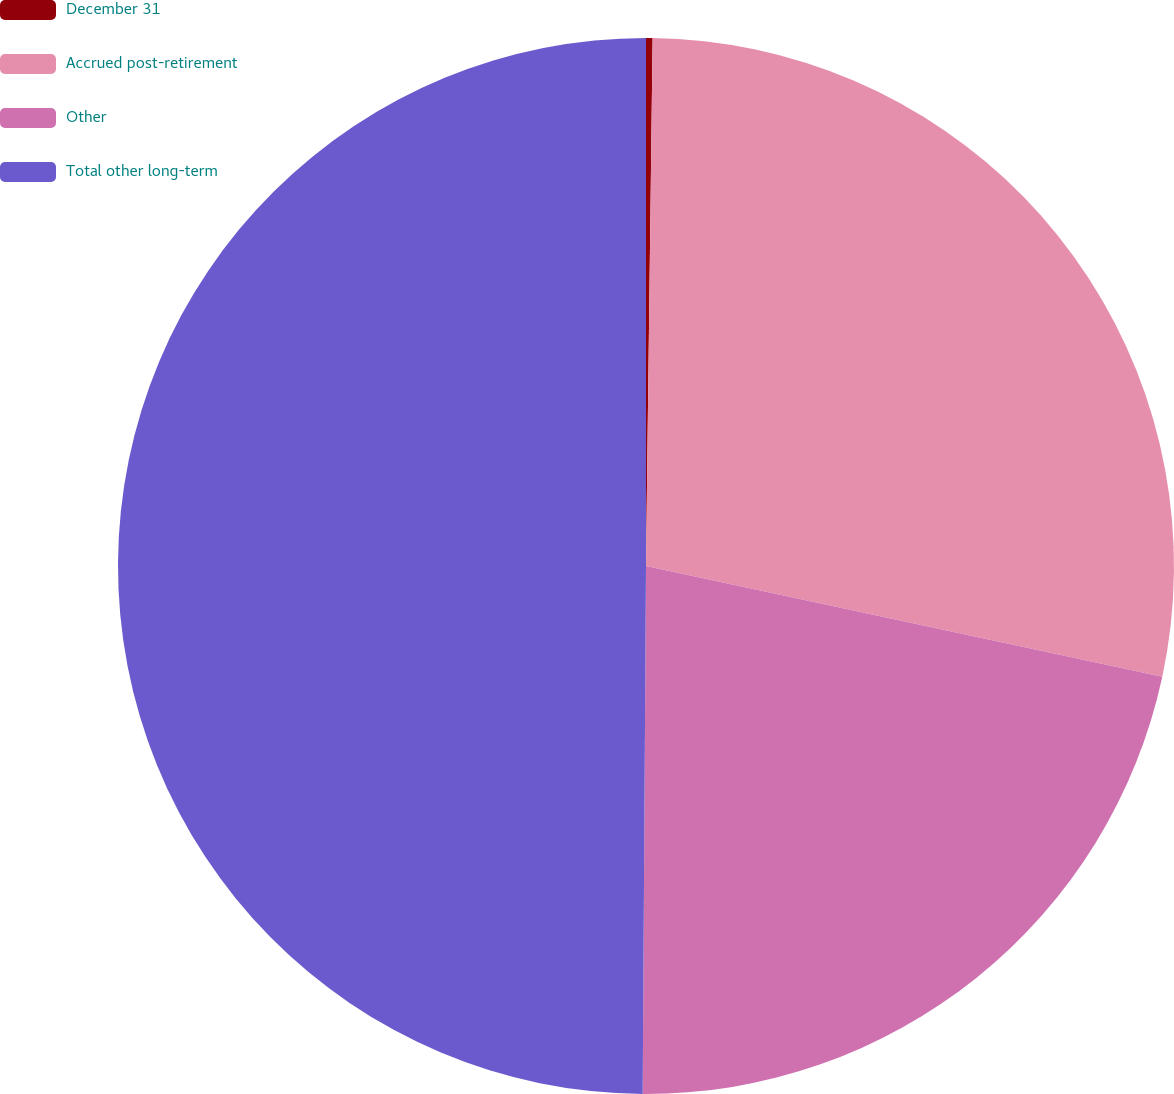Convert chart. <chart><loc_0><loc_0><loc_500><loc_500><pie_chart><fcel>December 31<fcel>Accrued post-retirement<fcel>Other<fcel>Total other long-term<nl><fcel>0.2%<fcel>28.16%<fcel>21.74%<fcel>49.9%<nl></chart> 